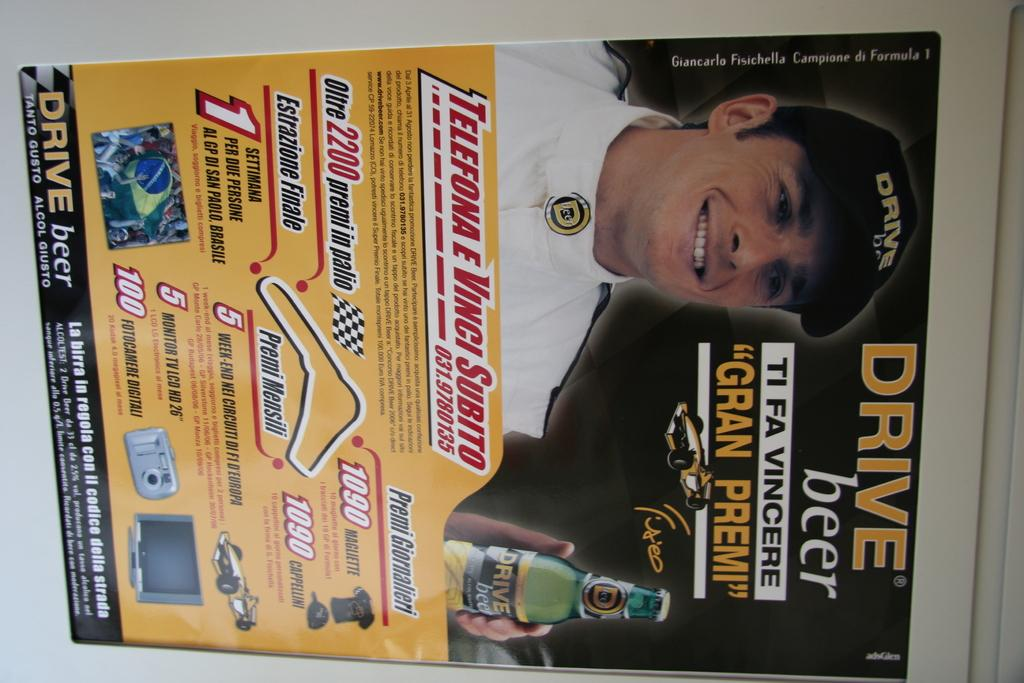What type of visual is the image? The image is a poster. What can be found on the poster besides the visual elements? There is text on the poster. Can you describe the person in the poster? The person in the poster is wearing a cap and holding a bottle. Reasoning: Let' Let's think step by step in order to produce the conversation. We start by identifying the type of image, which is a poster. Then, we mention the presence of text on the poster. Finally, we describe the person in the poster, focusing on their clothing and actions. Each question is designed to elicit a specific detail about the image that is known from the provided facts. Absurd Question/Answer: What type of guide can be seen in the poster? There is no guide present in the poster; it features a person wearing a cap and holding a bottle. What type of amusement is depicted in the poster? There is no amusement depicted in the poster; it is a poster with a person wearing a cap and holding a bottle. 